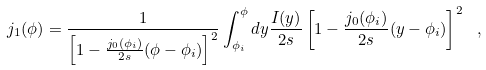<formula> <loc_0><loc_0><loc_500><loc_500>j _ { 1 } ( \phi ) = \frac { 1 } { \left [ 1 - \frac { j _ { 0 } ( \phi _ { i } ) } { 2 s } ( \phi - \phi _ { i } ) \right ] ^ { 2 } } \int _ { \phi _ { i } } ^ { \phi } d y \frac { I ( y ) } { 2 s } \left [ 1 - \frac { j _ { 0 } ( \phi _ { i } ) } { 2 s } ( y - \phi _ { i } ) \right ] ^ { 2 } \ ,</formula> 